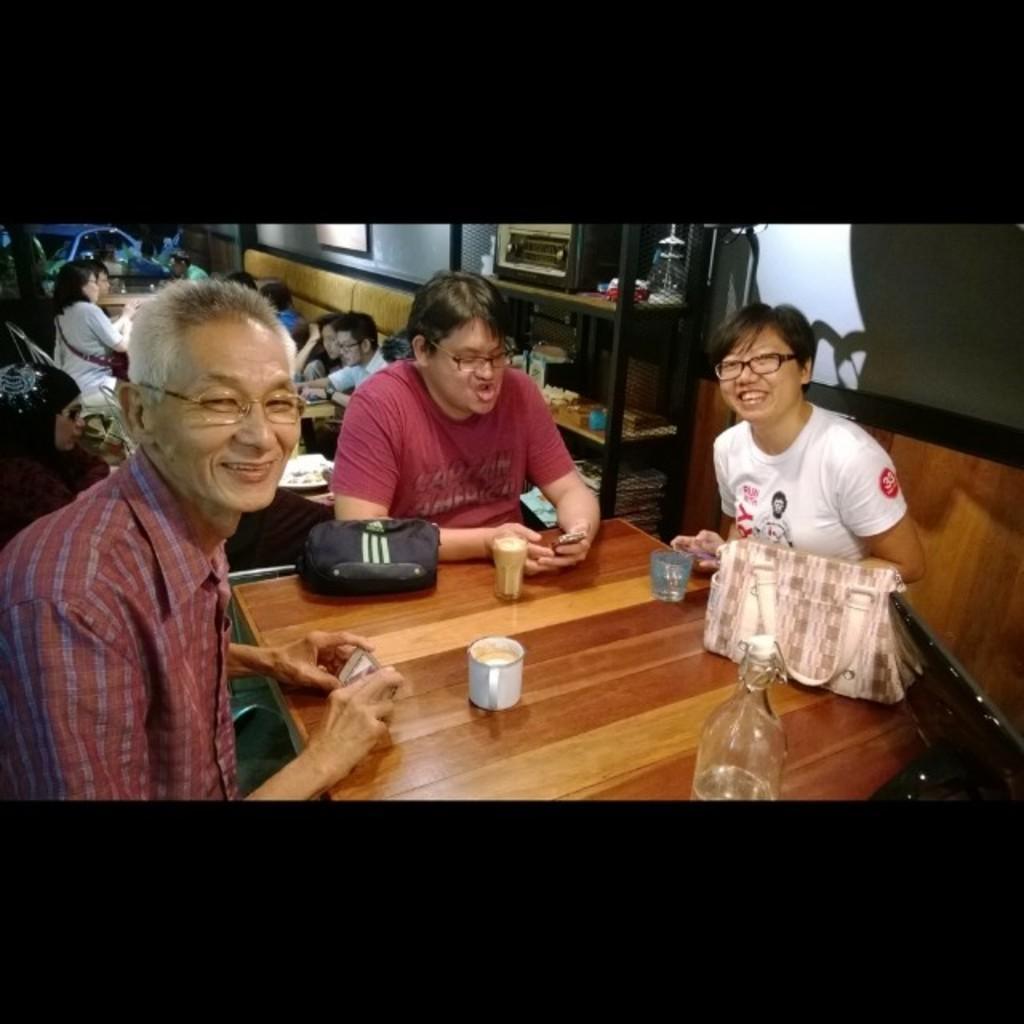Can you describe this image briefly? There are three people in the image. On the left side we can see a man who is smiling, holding his mobile and he is also having his glasses. On the table we can see a bag, a coffee cup, glass, handbag and a bottle. In the background we can see a woman who is sitting, there is a shelf which is attached to the wall and in the background we can also see a car. 